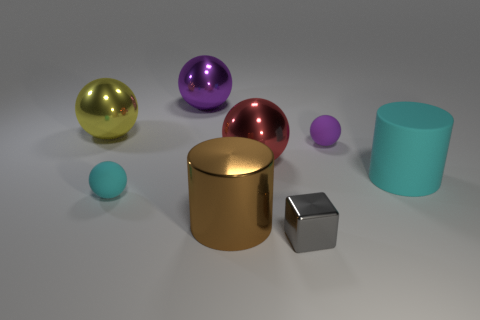Subtract all tiny cyan spheres. How many spheres are left? 4 Add 1 gray metal blocks. How many objects exist? 9 Subtract all cyan cylinders. How many cylinders are left? 1 Subtract 3 spheres. How many spheres are left? 2 Subtract all purple cubes. How many red cylinders are left? 0 Add 2 large brown cylinders. How many large brown cylinders are left? 3 Add 8 big yellow spheres. How many big yellow spheres exist? 9 Subtract 0 green spheres. How many objects are left? 8 Subtract all cubes. How many objects are left? 7 Subtract all green spheres. Subtract all gray cylinders. How many spheres are left? 5 